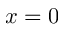<formula> <loc_0><loc_0><loc_500><loc_500>x = 0</formula> 